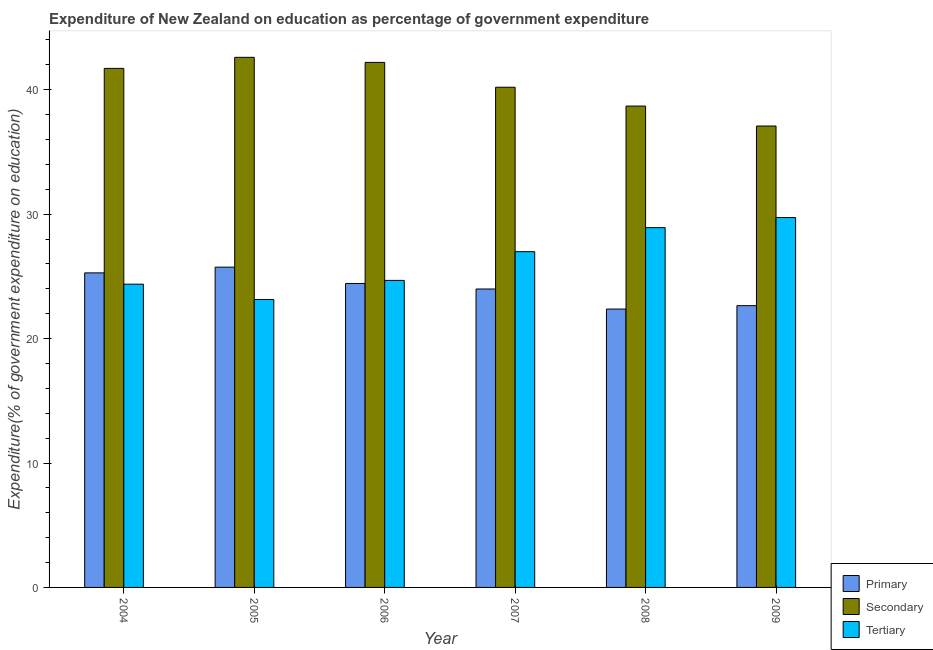How many groups of bars are there?
Ensure brevity in your answer.  6. Are the number of bars per tick equal to the number of legend labels?
Make the answer very short. Yes. How many bars are there on the 1st tick from the left?
Your response must be concise. 3. In how many cases, is the number of bars for a given year not equal to the number of legend labels?
Provide a succinct answer. 0. What is the expenditure on secondary education in 2006?
Provide a succinct answer. 42.2. Across all years, what is the maximum expenditure on tertiary education?
Provide a succinct answer. 29.73. Across all years, what is the minimum expenditure on primary education?
Keep it short and to the point. 22.37. In which year was the expenditure on secondary education maximum?
Ensure brevity in your answer.  2005. What is the total expenditure on secondary education in the graph?
Your answer should be compact. 242.5. What is the difference between the expenditure on primary education in 2006 and that in 2007?
Provide a short and direct response. 0.44. What is the difference between the expenditure on secondary education in 2004 and the expenditure on tertiary education in 2009?
Keep it short and to the point. 4.63. What is the average expenditure on tertiary education per year?
Ensure brevity in your answer.  26.3. In the year 2006, what is the difference between the expenditure on secondary education and expenditure on tertiary education?
Your response must be concise. 0. In how many years, is the expenditure on primary education greater than 16 %?
Your response must be concise. 6. What is the ratio of the expenditure on secondary education in 2007 to that in 2008?
Offer a very short reply. 1.04. Is the difference between the expenditure on secondary education in 2006 and 2008 greater than the difference between the expenditure on primary education in 2006 and 2008?
Give a very brief answer. No. What is the difference between the highest and the second highest expenditure on primary education?
Offer a very short reply. 0.46. What is the difference between the highest and the lowest expenditure on primary education?
Ensure brevity in your answer.  3.37. What does the 3rd bar from the left in 2004 represents?
Offer a very short reply. Tertiary. What does the 2nd bar from the right in 2009 represents?
Offer a terse response. Secondary. Is it the case that in every year, the sum of the expenditure on primary education and expenditure on secondary education is greater than the expenditure on tertiary education?
Your answer should be compact. Yes. How many bars are there?
Your answer should be compact. 18. Are all the bars in the graph horizontal?
Provide a succinct answer. No. Are the values on the major ticks of Y-axis written in scientific E-notation?
Provide a succinct answer. No. Does the graph contain any zero values?
Provide a succinct answer. No. Does the graph contain grids?
Provide a short and direct response. No. What is the title of the graph?
Offer a terse response. Expenditure of New Zealand on education as percentage of government expenditure. What is the label or title of the Y-axis?
Your response must be concise. Expenditure(% of government expenditure on education). What is the Expenditure(% of government expenditure on education) of Primary in 2004?
Provide a succinct answer. 25.28. What is the Expenditure(% of government expenditure on education) in Secondary in 2004?
Offer a very short reply. 41.72. What is the Expenditure(% of government expenditure on education) in Tertiary in 2004?
Your answer should be very brief. 24.37. What is the Expenditure(% of government expenditure on education) of Primary in 2005?
Make the answer very short. 25.74. What is the Expenditure(% of government expenditure on education) of Secondary in 2005?
Give a very brief answer. 42.61. What is the Expenditure(% of government expenditure on education) of Tertiary in 2005?
Make the answer very short. 23.14. What is the Expenditure(% of government expenditure on education) in Primary in 2006?
Keep it short and to the point. 24.43. What is the Expenditure(% of government expenditure on education) of Secondary in 2006?
Offer a very short reply. 42.2. What is the Expenditure(% of government expenditure on education) of Tertiary in 2006?
Your response must be concise. 24.68. What is the Expenditure(% of government expenditure on education) of Primary in 2007?
Your answer should be very brief. 23.99. What is the Expenditure(% of government expenditure on education) in Secondary in 2007?
Make the answer very short. 40.2. What is the Expenditure(% of government expenditure on education) in Tertiary in 2007?
Your answer should be very brief. 26.99. What is the Expenditure(% of government expenditure on education) in Primary in 2008?
Provide a short and direct response. 22.37. What is the Expenditure(% of government expenditure on education) of Secondary in 2008?
Your answer should be compact. 38.69. What is the Expenditure(% of government expenditure on education) in Tertiary in 2008?
Provide a succinct answer. 28.92. What is the Expenditure(% of government expenditure on education) of Primary in 2009?
Ensure brevity in your answer.  22.65. What is the Expenditure(% of government expenditure on education) of Secondary in 2009?
Provide a short and direct response. 37.09. What is the Expenditure(% of government expenditure on education) in Tertiary in 2009?
Provide a short and direct response. 29.73. Across all years, what is the maximum Expenditure(% of government expenditure on education) in Primary?
Make the answer very short. 25.74. Across all years, what is the maximum Expenditure(% of government expenditure on education) of Secondary?
Make the answer very short. 42.61. Across all years, what is the maximum Expenditure(% of government expenditure on education) in Tertiary?
Keep it short and to the point. 29.73. Across all years, what is the minimum Expenditure(% of government expenditure on education) in Primary?
Offer a terse response. 22.37. Across all years, what is the minimum Expenditure(% of government expenditure on education) of Secondary?
Offer a very short reply. 37.09. Across all years, what is the minimum Expenditure(% of government expenditure on education) in Tertiary?
Provide a succinct answer. 23.14. What is the total Expenditure(% of government expenditure on education) in Primary in the graph?
Ensure brevity in your answer.  144.46. What is the total Expenditure(% of government expenditure on education) in Secondary in the graph?
Ensure brevity in your answer.  242.5. What is the total Expenditure(% of government expenditure on education) in Tertiary in the graph?
Your response must be concise. 157.82. What is the difference between the Expenditure(% of government expenditure on education) in Primary in 2004 and that in 2005?
Make the answer very short. -0.46. What is the difference between the Expenditure(% of government expenditure on education) of Secondary in 2004 and that in 2005?
Provide a succinct answer. -0.89. What is the difference between the Expenditure(% of government expenditure on education) in Tertiary in 2004 and that in 2005?
Ensure brevity in your answer.  1.23. What is the difference between the Expenditure(% of government expenditure on education) in Primary in 2004 and that in 2006?
Offer a very short reply. 0.85. What is the difference between the Expenditure(% of government expenditure on education) of Secondary in 2004 and that in 2006?
Provide a short and direct response. -0.48. What is the difference between the Expenditure(% of government expenditure on education) in Tertiary in 2004 and that in 2006?
Your response must be concise. -0.3. What is the difference between the Expenditure(% of government expenditure on education) of Primary in 2004 and that in 2007?
Your response must be concise. 1.29. What is the difference between the Expenditure(% of government expenditure on education) of Secondary in 2004 and that in 2007?
Your answer should be compact. 1.51. What is the difference between the Expenditure(% of government expenditure on education) in Tertiary in 2004 and that in 2007?
Your response must be concise. -2.61. What is the difference between the Expenditure(% of government expenditure on education) in Primary in 2004 and that in 2008?
Provide a short and direct response. 2.91. What is the difference between the Expenditure(% of government expenditure on education) in Secondary in 2004 and that in 2008?
Your response must be concise. 3.03. What is the difference between the Expenditure(% of government expenditure on education) of Tertiary in 2004 and that in 2008?
Keep it short and to the point. -4.54. What is the difference between the Expenditure(% of government expenditure on education) in Primary in 2004 and that in 2009?
Your answer should be very brief. 2.63. What is the difference between the Expenditure(% of government expenditure on education) of Secondary in 2004 and that in 2009?
Provide a succinct answer. 4.63. What is the difference between the Expenditure(% of government expenditure on education) of Tertiary in 2004 and that in 2009?
Your response must be concise. -5.35. What is the difference between the Expenditure(% of government expenditure on education) in Primary in 2005 and that in 2006?
Make the answer very short. 1.31. What is the difference between the Expenditure(% of government expenditure on education) of Secondary in 2005 and that in 2006?
Your answer should be compact. 0.41. What is the difference between the Expenditure(% of government expenditure on education) of Tertiary in 2005 and that in 2006?
Your response must be concise. -1.53. What is the difference between the Expenditure(% of government expenditure on education) in Primary in 2005 and that in 2007?
Provide a short and direct response. 1.76. What is the difference between the Expenditure(% of government expenditure on education) in Secondary in 2005 and that in 2007?
Your answer should be compact. 2.4. What is the difference between the Expenditure(% of government expenditure on education) in Tertiary in 2005 and that in 2007?
Give a very brief answer. -3.84. What is the difference between the Expenditure(% of government expenditure on education) of Primary in 2005 and that in 2008?
Make the answer very short. 3.37. What is the difference between the Expenditure(% of government expenditure on education) of Secondary in 2005 and that in 2008?
Keep it short and to the point. 3.92. What is the difference between the Expenditure(% of government expenditure on education) of Tertiary in 2005 and that in 2008?
Keep it short and to the point. -5.78. What is the difference between the Expenditure(% of government expenditure on education) of Primary in 2005 and that in 2009?
Provide a succinct answer. 3.1. What is the difference between the Expenditure(% of government expenditure on education) of Secondary in 2005 and that in 2009?
Your answer should be compact. 5.52. What is the difference between the Expenditure(% of government expenditure on education) of Tertiary in 2005 and that in 2009?
Keep it short and to the point. -6.58. What is the difference between the Expenditure(% of government expenditure on education) in Primary in 2006 and that in 2007?
Provide a short and direct response. 0.44. What is the difference between the Expenditure(% of government expenditure on education) of Secondary in 2006 and that in 2007?
Offer a very short reply. 2. What is the difference between the Expenditure(% of government expenditure on education) of Tertiary in 2006 and that in 2007?
Offer a terse response. -2.31. What is the difference between the Expenditure(% of government expenditure on education) in Primary in 2006 and that in 2008?
Your response must be concise. 2.06. What is the difference between the Expenditure(% of government expenditure on education) of Secondary in 2006 and that in 2008?
Your answer should be very brief. 3.51. What is the difference between the Expenditure(% of government expenditure on education) of Tertiary in 2006 and that in 2008?
Give a very brief answer. -4.24. What is the difference between the Expenditure(% of government expenditure on education) in Primary in 2006 and that in 2009?
Your answer should be compact. 1.78. What is the difference between the Expenditure(% of government expenditure on education) in Secondary in 2006 and that in 2009?
Give a very brief answer. 5.11. What is the difference between the Expenditure(% of government expenditure on education) in Tertiary in 2006 and that in 2009?
Provide a succinct answer. -5.05. What is the difference between the Expenditure(% of government expenditure on education) in Primary in 2007 and that in 2008?
Provide a succinct answer. 1.61. What is the difference between the Expenditure(% of government expenditure on education) of Secondary in 2007 and that in 2008?
Keep it short and to the point. 1.51. What is the difference between the Expenditure(% of government expenditure on education) of Tertiary in 2007 and that in 2008?
Provide a succinct answer. -1.93. What is the difference between the Expenditure(% of government expenditure on education) in Primary in 2007 and that in 2009?
Offer a very short reply. 1.34. What is the difference between the Expenditure(% of government expenditure on education) in Secondary in 2007 and that in 2009?
Give a very brief answer. 3.12. What is the difference between the Expenditure(% of government expenditure on education) of Tertiary in 2007 and that in 2009?
Offer a terse response. -2.74. What is the difference between the Expenditure(% of government expenditure on education) of Primary in 2008 and that in 2009?
Make the answer very short. -0.27. What is the difference between the Expenditure(% of government expenditure on education) of Secondary in 2008 and that in 2009?
Your answer should be compact. 1.6. What is the difference between the Expenditure(% of government expenditure on education) of Tertiary in 2008 and that in 2009?
Keep it short and to the point. -0.81. What is the difference between the Expenditure(% of government expenditure on education) in Primary in 2004 and the Expenditure(% of government expenditure on education) in Secondary in 2005?
Ensure brevity in your answer.  -17.32. What is the difference between the Expenditure(% of government expenditure on education) in Primary in 2004 and the Expenditure(% of government expenditure on education) in Tertiary in 2005?
Offer a very short reply. 2.14. What is the difference between the Expenditure(% of government expenditure on education) in Secondary in 2004 and the Expenditure(% of government expenditure on education) in Tertiary in 2005?
Keep it short and to the point. 18.57. What is the difference between the Expenditure(% of government expenditure on education) in Primary in 2004 and the Expenditure(% of government expenditure on education) in Secondary in 2006?
Your answer should be compact. -16.92. What is the difference between the Expenditure(% of government expenditure on education) in Primary in 2004 and the Expenditure(% of government expenditure on education) in Tertiary in 2006?
Offer a terse response. 0.6. What is the difference between the Expenditure(% of government expenditure on education) in Secondary in 2004 and the Expenditure(% of government expenditure on education) in Tertiary in 2006?
Your answer should be very brief. 17.04. What is the difference between the Expenditure(% of government expenditure on education) of Primary in 2004 and the Expenditure(% of government expenditure on education) of Secondary in 2007?
Your answer should be very brief. -14.92. What is the difference between the Expenditure(% of government expenditure on education) of Primary in 2004 and the Expenditure(% of government expenditure on education) of Tertiary in 2007?
Your answer should be compact. -1.71. What is the difference between the Expenditure(% of government expenditure on education) of Secondary in 2004 and the Expenditure(% of government expenditure on education) of Tertiary in 2007?
Provide a short and direct response. 14.73. What is the difference between the Expenditure(% of government expenditure on education) of Primary in 2004 and the Expenditure(% of government expenditure on education) of Secondary in 2008?
Provide a short and direct response. -13.41. What is the difference between the Expenditure(% of government expenditure on education) in Primary in 2004 and the Expenditure(% of government expenditure on education) in Tertiary in 2008?
Ensure brevity in your answer.  -3.64. What is the difference between the Expenditure(% of government expenditure on education) in Secondary in 2004 and the Expenditure(% of government expenditure on education) in Tertiary in 2008?
Ensure brevity in your answer.  12.8. What is the difference between the Expenditure(% of government expenditure on education) of Primary in 2004 and the Expenditure(% of government expenditure on education) of Secondary in 2009?
Ensure brevity in your answer.  -11.81. What is the difference between the Expenditure(% of government expenditure on education) in Primary in 2004 and the Expenditure(% of government expenditure on education) in Tertiary in 2009?
Ensure brevity in your answer.  -4.45. What is the difference between the Expenditure(% of government expenditure on education) in Secondary in 2004 and the Expenditure(% of government expenditure on education) in Tertiary in 2009?
Ensure brevity in your answer.  11.99. What is the difference between the Expenditure(% of government expenditure on education) of Primary in 2005 and the Expenditure(% of government expenditure on education) of Secondary in 2006?
Provide a short and direct response. -16.46. What is the difference between the Expenditure(% of government expenditure on education) in Primary in 2005 and the Expenditure(% of government expenditure on education) in Tertiary in 2006?
Make the answer very short. 1.06. What is the difference between the Expenditure(% of government expenditure on education) of Secondary in 2005 and the Expenditure(% of government expenditure on education) of Tertiary in 2006?
Your response must be concise. 17.93. What is the difference between the Expenditure(% of government expenditure on education) of Primary in 2005 and the Expenditure(% of government expenditure on education) of Secondary in 2007?
Offer a very short reply. -14.46. What is the difference between the Expenditure(% of government expenditure on education) of Primary in 2005 and the Expenditure(% of government expenditure on education) of Tertiary in 2007?
Offer a very short reply. -1.24. What is the difference between the Expenditure(% of government expenditure on education) of Secondary in 2005 and the Expenditure(% of government expenditure on education) of Tertiary in 2007?
Provide a short and direct response. 15.62. What is the difference between the Expenditure(% of government expenditure on education) in Primary in 2005 and the Expenditure(% of government expenditure on education) in Secondary in 2008?
Your answer should be very brief. -12.95. What is the difference between the Expenditure(% of government expenditure on education) in Primary in 2005 and the Expenditure(% of government expenditure on education) in Tertiary in 2008?
Your response must be concise. -3.18. What is the difference between the Expenditure(% of government expenditure on education) of Secondary in 2005 and the Expenditure(% of government expenditure on education) of Tertiary in 2008?
Provide a succinct answer. 13.69. What is the difference between the Expenditure(% of government expenditure on education) of Primary in 2005 and the Expenditure(% of government expenditure on education) of Secondary in 2009?
Provide a short and direct response. -11.34. What is the difference between the Expenditure(% of government expenditure on education) of Primary in 2005 and the Expenditure(% of government expenditure on education) of Tertiary in 2009?
Ensure brevity in your answer.  -3.99. What is the difference between the Expenditure(% of government expenditure on education) of Secondary in 2005 and the Expenditure(% of government expenditure on education) of Tertiary in 2009?
Ensure brevity in your answer.  12.88. What is the difference between the Expenditure(% of government expenditure on education) of Primary in 2006 and the Expenditure(% of government expenditure on education) of Secondary in 2007?
Ensure brevity in your answer.  -15.77. What is the difference between the Expenditure(% of government expenditure on education) in Primary in 2006 and the Expenditure(% of government expenditure on education) in Tertiary in 2007?
Offer a terse response. -2.56. What is the difference between the Expenditure(% of government expenditure on education) in Secondary in 2006 and the Expenditure(% of government expenditure on education) in Tertiary in 2007?
Your response must be concise. 15.21. What is the difference between the Expenditure(% of government expenditure on education) of Primary in 2006 and the Expenditure(% of government expenditure on education) of Secondary in 2008?
Provide a succinct answer. -14.26. What is the difference between the Expenditure(% of government expenditure on education) in Primary in 2006 and the Expenditure(% of government expenditure on education) in Tertiary in 2008?
Offer a very short reply. -4.49. What is the difference between the Expenditure(% of government expenditure on education) of Secondary in 2006 and the Expenditure(% of government expenditure on education) of Tertiary in 2008?
Keep it short and to the point. 13.28. What is the difference between the Expenditure(% of government expenditure on education) in Primary in 2006 and the Expenditure(% of government expenditure on education) in Secondary in 2009?
Provide a succinct answer. -12.66. What is the difference between the Expenditure(% of government expenditure on education) of Primary in 2006 and the Expenditure(% of government expenditure on education) of Tertiary in 2009?
Make the answer very short. -5.3. What is the difference between the Expenditure(% of government expenditure on education) of Secondary in 2006 and the Expenditure(% of government expenditure on education) of Tertiary in 2009?
Offer a terse response. 12.47. What is the difference between the Expenditure(% of government expenditure on education) of Primary in 2007 and the Expenditure(% of government expenditure on education) of Secondary in 2008?
Keep it short and to the point. -14.7. What is the difference between the Expenditure(% of government expenditure on education) of Primary in 2007 and the Expenditure(% of government expenditure on education) of Tertiary in 2008?
Keep it short and to the point. -4.93. What is the difference between the Expenditure(% of government expenditure on education) in Secondary in 2007 and the Expenditure(% of government expenditure on education) in Tertiary in 2008?
Give a very brief answer. 11.28. What is the difference between the Expenditure(% of government expenditure on education) in Primary in 2007 and the Expenditure(% of government expenditure on education) in Secondary in 2009?
Ensure brevity in your answer.  -13.1. What is the difference between the Expenditure(% of government expenditure on education) of Primary in 2007 and the Expenditure(% of government expenditure on education) of Tertiary in 2009?
Your answer should be very brief. -5.74. What is the difference between the Expenditure(% of government expenditure on education) of Secondary in 2007 and the Expenditure(% of government expenditure on education) of Tertiary in 2009?
Ensure brevity in your answer.  10.47. What is the difference between the Expenditure(% of government expenditure on education) of Primary in 2008 and the Expenditure(% of government expenditure on education) of Secondary in 2009?
Offer a terse response. -14.71. What is the difference between the Expenditure(% of government expenditure on education) in Primary in 2008 and the Expenditure(% of government expenditure on education) in Tertiary in 2009?
Ensure brevity in your answer.  -7.35. What is the difference between the Expenditure(% of government expenditure on education) of Secondary in 2008 and the Expenditure(% of government expenditure on education) of Tertiary in 2009?
Make the answer very short. 8.96. What is the average Expenditure(% of government expenditure on education) of Primary per year?
Provide a short and direct response. 24.08. What is the average Expenditure(% of government expenditure on education) in Secondary per year?
Keep it short and to the point. 40.42. What is the average Expenditure(% of government expenditure on education) of Tertiary per year?
Make the answer very short. 26.3. In the year 2004, what is the difference between the Expenditure(% of government expenditure on education) of Primary and Expenditure(% of government expenditure on education) of Secondary?
Offer a terse response. -16.44. In the year 2004, what is the difference between the Expenditure(% of government expenditure on education) in Primary and Expenditure(% of government expenditure on education) in Tertiary?
Offer a very short reply. 0.91. In the year 2004, what is the difference between the Expenditure(% of government expenditure on education) of Secondary and Expenditure(% of government expenditure on education) of Tertiary?
Offer a terse response. 17.34. In the year 2005, what is the difference between the Expenditure(% of government expenditure on education) in Primary and Expenditure(% of government expenditure on education) in Secondary?
Give a very brief answer. -16.86. In the year 2005, what is the difference between the Expenditure(% of government expenditure on education) of Primary and Expenditure(% of government expenditure on education) of Tertiary?
Provide a succinct answer. 2.6. In the year 2005, what is the difference between the Expenditure(% of government expenditure on education) of Secondary and Expenditure(% of government expenditure on education) of Tertiary?
Offer a terse response. 19.46. In the year 2006, what is the difference between the Expenditure(% of government expenditure on education) in Primary and Expenditure(% of government expenditure on education) in Secondary?
Provide a succinct answer. -17.77. In the year 2006, what is the difference between the Expenditure(% of government expenditure on education) in Primary and Expenditure(% of government expenditure on education) in Tertiary?
Your answer should be compact. -0.25. In the year 2006, what is the difference between the Expenditure(% of government expenditure on education) in Secondary and Expenditure(% of government expenditure on education) in Tertiary?
Your response must be concise. 17.52. In the year 2007, what is the difference between the Expenditure(% of government expenditure on education) in Primary and Expenditure(% of government expenditure on education) in Secondary?
Provide a short and direct response. -16.22. In the year 2007, what is the difference between the Expenditure(% of government expenditure on education) in Primary and Expenditure(% of government expenditure on education) in Tertiary?
Make the answer very short. -3. In the year 2007, what is the difference between the Expenditure(% of government expenditure on education) in Secondary and Expenditure(% of government expenditure on education) in Tertiary?
Make the answer very short. 13.22. In the year 2008, what is the difference between the Expenditure(% of government expenditure on education) in Primary and Expenditure(% of government expenditure on education) in Secondary?
Make the answer very short. -16.32. In the year 2008, what is the difference between the Expenditure(% of government expenditure on education) of Primary and Expenditure(% of government expenditure on education) of Tertiary?
Your response must be concise. -6.54. In the year 2008, what is the difference between the Expenditure(% of government expenditure on education) of Secondary and Expenditure(% of government expenditure on education) of Tertiary?
Your answer should be compact. 9.77. In the year 2009, what is the difference between the Expenditure(% of government expenditure on education) of Primary and Expenditure(% of government expenditure on education) of Secondary?
Ensure brevity in your answer.  -14.44. In the year 2009, what is the difference between the Expenditure(% of government expenditure on education) in Primary and Expenditure(% of government expenditure on education) in Tertiary?
Your answer should be very brief. -7.08. In the year 2009, what is the difference between the Expenditure(% of government expenditure on education) in Secondary and Expenditure(% of government expenditure on education) in Tertiary?
Offer a very short reply. 7.36. What is the ratio of the Expenditure(% of government expenditure on education) in Primary in 2004 to that in 2005?
Provide a short and direct response. 0.98. What is the ratio of the Expenditure(% of government expenditure on education) in Secondary in 2004 to that in 2005?
Provide a succinct answer. 0.98. What is the ratio of the Expenditure(% of government expenditure on education) in Tertiary in 2004 to that in 2005?
Give a very brief answer. 1.05. What is the ratio of the Expenditure(% of government expenditure on education) in Primary in 2004 to that in 2006?
Make the answer very short. 1.03. What is the ratio of the Expenditure(% of government expenditure on education) of Primary in 2004 to that in 2007?
Provide a succinct answer. 1.05. What is the ratio of the Expenditure(% of government expenditure on education) of Secondary in 2004 to that in 2007?
Make the answer very short. 1.04. What is the ratio of the Expenditure(% of government expenditure on education) in Tertiary in 2004 to that in 2007?
Offer a terse response. 0.9. What is the ratio of the Expenditure(% of government expenditure on education) in Primary in 2004 to that in 2008?
Make the answer very short. 1.13. What is the ratio of the Expenditure(% of government expenditure on education) in Secondary in 2004 to that in 2008?
Offer a terse response. 1.08. What is the ratio of the Expenditure(% of government expenditure on education) in Tertiary in 2004 to that in 2008?
Your answer should be very brief. 0.84. What is the ratio of the Expenditure(% of government expenditure on education) in Primary in 2004 to that in 2009?
Provide a short and direct response. 1.12. What is the ratio of the Expenditure(% of government expenditure on education) of Secondary in 2004 to that in 2009?
Keep it short and to the point. 1.12. What is the ratio of the Expenditure(% of government expenditure on education) of Tertiary in 2004 to that in 2009?
Give a very brief answer. 0.82. What is the ratio of the Expenditure(% of government expenditure on education) in Primary in 2005 to that in 2006?
Give a very brief answer. 1.05. What is the ratio of the Expenditure(% of government expenditure on education) of Secondary in 2005 to that in 2006?
Your answer should be compact. 1.01. What is the ratio of the Expenditure(% of government expenditure on education) in Tertiary in 2005 to that in 2006?
Offer a very short reply. 0.94. What is the ratio of the Expenditure(% of government expenditure on education) in Primary in 2005 to that in 2007?
Make the answer very short. 1.07. What is the ratio of the Expenditure(% of government expenditure on education) in Secondary in 2005 to that in 2007?
Ensure brevity in your answer.  1.06. What is the ratio of the Expenditure(% of government expenditure on education) in Tertiary in 2005 to that in 2007?
Offer a terse response. 0.86. What is the ratio of the Expenditure(% of government expenditure on education) in Primary in 2005 to that in 2008?
Your answer should be very brief. 1.15. What is the ratio of the Expenditure(% of government expenditure on education) of Secondary in 2005 to that in 2008?
Keep it short and to the point. 1.1. What is the ratio of the Expenditure(% of government expenditure on education) of Tertiary in 2005 to that in 2008?
Offer a terse response. 0.8. What is the ratio of the Expenditure(% of government expenditure on education) of Primary in 2005 to that in 2009?
Your answer should be compact. 1.14. What is the ratio of the Expenditure(% of government expenditure on education) of Secondary in 2005 to that in 2009?
Offer a very short reply. 1.15. What is the ratio of the Expenditure(% of government expenditure on education) of Tertiary in 2005 to that in 2009?
Your response must be concise. 0.78. What is the ratio of the Expenditure(% of government expenditure on education) in Primary in 2006 to that in 2007?
Provide a short and direct response. 1.02. What is the ratio of the Expenditure(% of government expenditure on education) of Secondary in 2006 to that in 2007?
Your response must be concise. 1.05. What is the ratio of the Expenditure(% of government expenditure on education) in Tertiary in 2006 to that in 2007?
Make the answer very short. 0.91. What is the ratio of the Expenditure(% of government expenditure on education) in Primary in 2006 to that in 2008?
Offer a terse response. 1.09. What is the ratio of the Expenditure(% of government expenditure on education) of Secondary in 2006 to that in 2008?
Your response must be concise. 1.09. What is the ratio of the Expenditure(% of government expenditure on education) in Tertiary in 2006 to that in 2008?
Offer a very short reply. 0.85. What is the ratio of the Expenditure(% of government expenditure on education) in Primary in 2006 to that in 2009?
Make the answer very short. 1.08. What is the ratio of the Expenditure(% of government expenditure on education) of Secondary in 2006 to that in 2009?
Give a very brief answer. 1.14. What is the ratio of the Expenditure(% of government expenditure on education) in Tertiary in 2006 to that in 2009?
Keep it short and to the point. 0.83. What is the ratio of the Expenditure(% of government expenditure on education) in Primary in 2007 to that in 2008?
Ensure brevity in your answer.  1.07. What is the ratio of the Expenditure(% of government expenditure on education) in Secondary in 2007 to that in 2008?
Your answer should be very brief. 1.04. What is the ratio of the Expenditure(% of government expenditure on education) of Tertiary in 2007 to that in 2008?
Your answer should be compact. 0.93. What is the ratio of the Expenditure(% of government expenditure on education) of Primary in 2007 to that in 2009?
Offer a terse response. 1.06. What is the ratio of the Expenditure(% of government expenditure on education) of Secondary in 2007 to that in 2009?
Your response must be concise. 1.08. What is the ratio of the Expenditure(% of government expenditure on education) in Tertiary in 2007 to that in 2009?
Ensure brevity in your answer.  0.91. What is the ratio of the Expenditure(% of government expenditure on education) in Primary in 2008 to that in 2009?
Ensure brevity in your answer.  0.99. What is the ratio of the Expenditure(% of government expenditure on education) in Secondary in 2008 to that in 2009?
Keep it short and to the point. 1.04. What is the ratio of the Expenditure(% of government expenditure on education) of Tertiary in 2008 to that in 2009?
Provide a succinct answer. 0.97. What is the difference between the highest and the second highest Expenditure(% of government expenditure on education) in Primary?
Your answer should be very brief. 0.46. What is the difference between the highest and the second highest Expenditure(% of government expenditure on education) of Secondary?
Your answer should be compact. 0.41. What is the difference between the highest and the second highest Expenditure(% of government expenditure on education) of Tertiary?
Ensure brevity in your answer.  0.81. What is the difference between the highest and the lowest Expenditure(% of government expenditure on education) in Primary?
Offer a very short reply. 3.37. What is the difference between the highest and the lowest Expenditure(% of government expenditure on education) of Secondary?
Ensure brevity in your answer.  5.52. What is the difference between the highest and the lowest Expenditure(% of government expenditure on education) of Tertiary?
Your response must be concise. 6.58. 